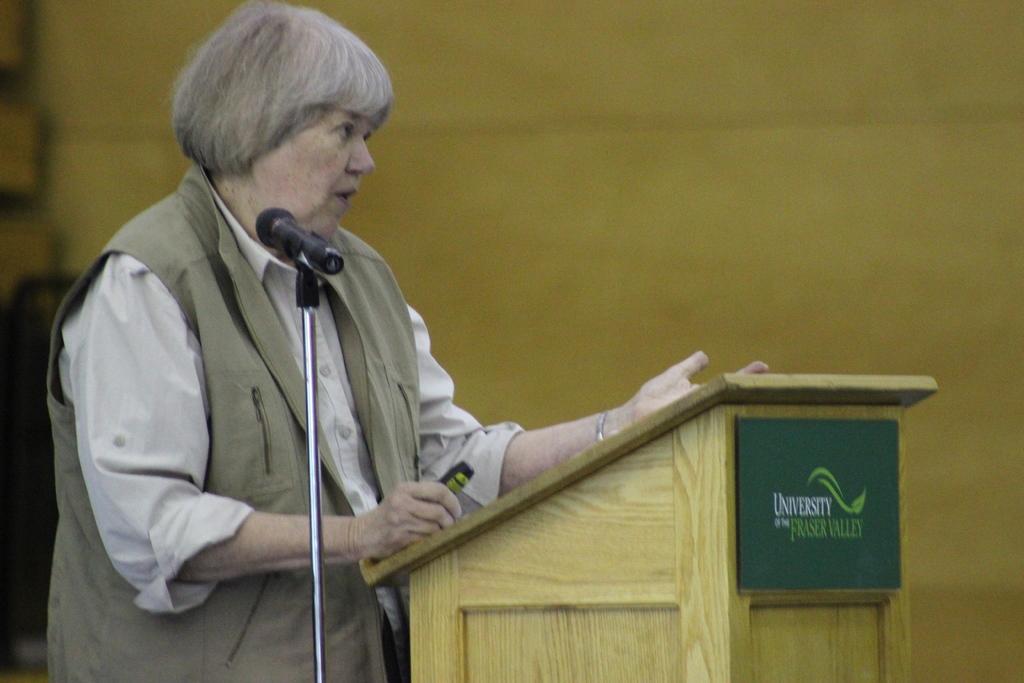How would you summarize this image in a sentence or two? There is a person standing and holding an object, in front of this person we can see board on the podium, beside this person we can see microphone with stand. In the background it is blue and cream color. 